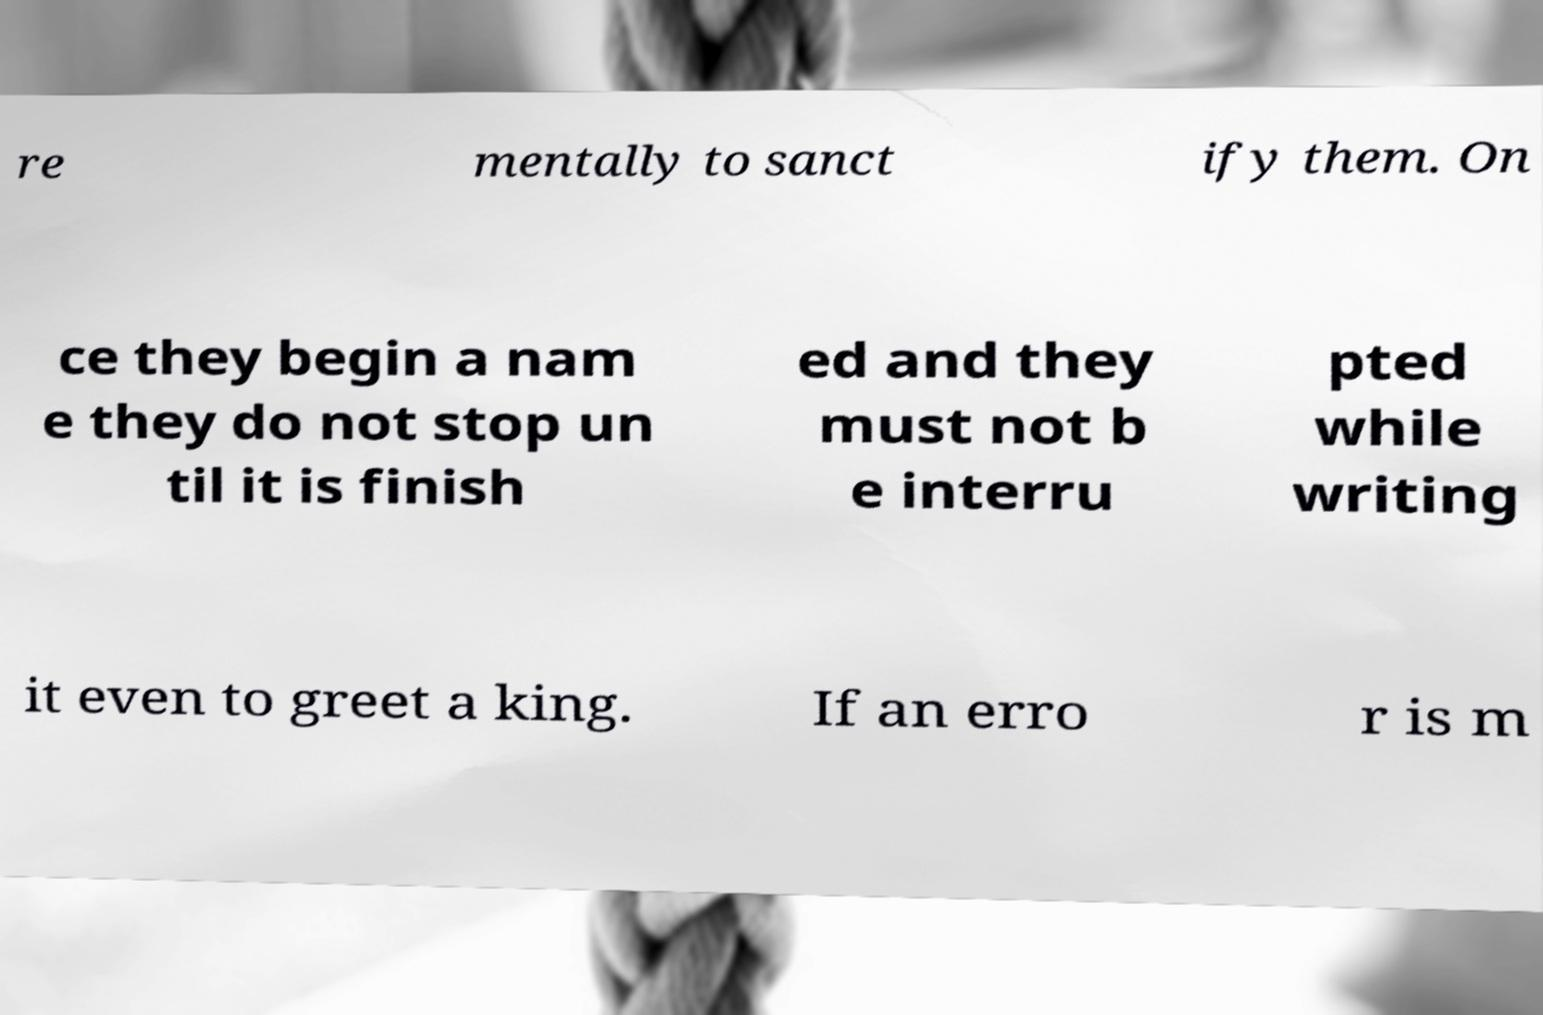For documentation purposes, I need the text within this image transcribed. Could you provide that? re mentally to sanct ify them. On ce they begin a nam e they do not stop un til it is finish ed and they must not b e interru pted while writing it even to greet a king. If an erro r is m 